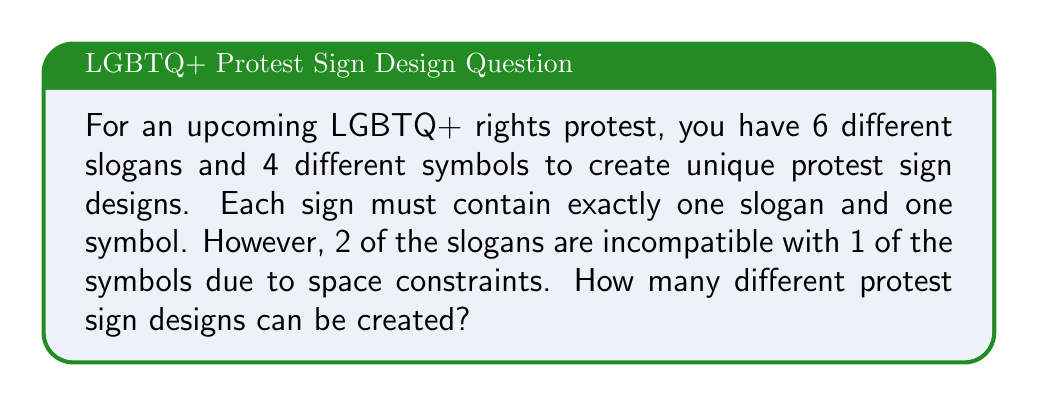Provide a solution to this math problem. Let's approach this step-by-step:

1) Without any restrictions, the total number of combinations would be:
   $6 \text{ slogans} \times 4 \text{ symbols} = 24$ designs

2) However, we need to subtract the incompatible combinations:
   $2 \text{ slogans} \times 1 \text{ symbol} = 2$ incompatible designs

3) Therefore, the total number of possible designs is:
   $24 - 2 = 22$ designs

We can also express this using the multiplication principle and the subtraction principle:

$$\text{Total designs} = (6 \times 4) - (2 \times 1) = 24 - 2 = 22$$

This problem is an application of the basic counting principle in combinatorics, with an additional constraint that requires us to subtract certain combinations.
Answer: 22 